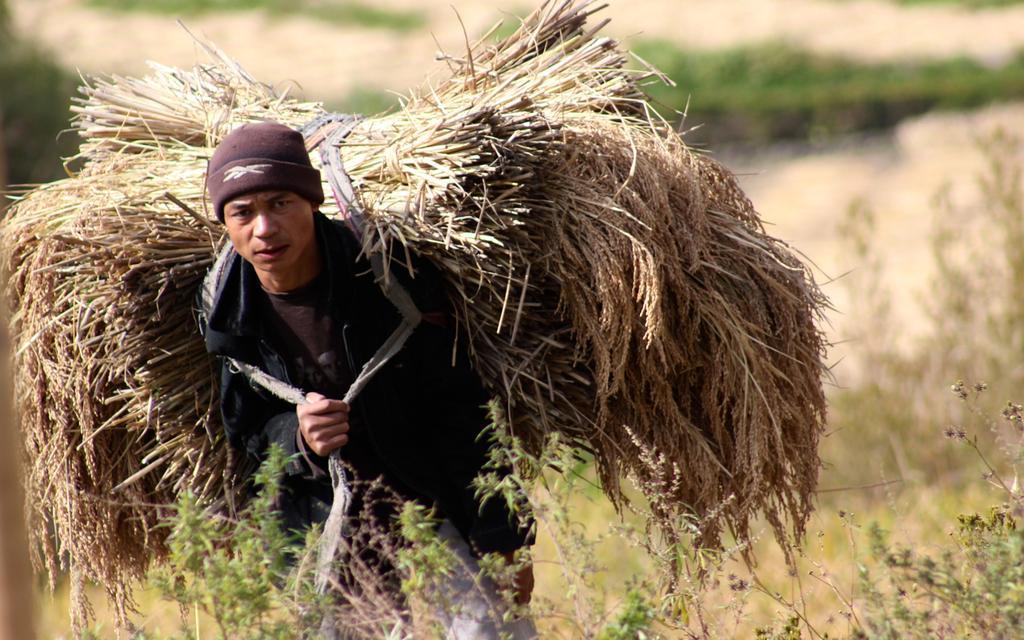Please provide a concise description of this image. Background portion of the picture is blur. In this picture we can see a man wearing a cap, jacket. He is carrying bunch of plants which are tied together with a rope on his shoulder. At the bottom portion of the picture we can see the plants. 